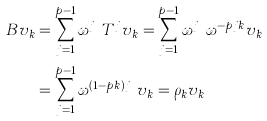<formula> <loc_0><loc_0><loc_500><loc_500>B v _ { k } & = \sum _ { j = 1 } ^ { p - 1 } \omega ^ { j ^ { p } } T ^ { j } v _ { k } = \sum _ { j = 1 } ^ { p - 1 } \omega ^ { j ^ { p } } \omega ^ { - p j k } v _ { k } \\ & = \sum _ { j = 1 } ^ { p - 1 } \omega ^ { ( 1 - p k ) j ^ { p } } v _ { k } = \rho _ { k } v _ { k }</formula> 